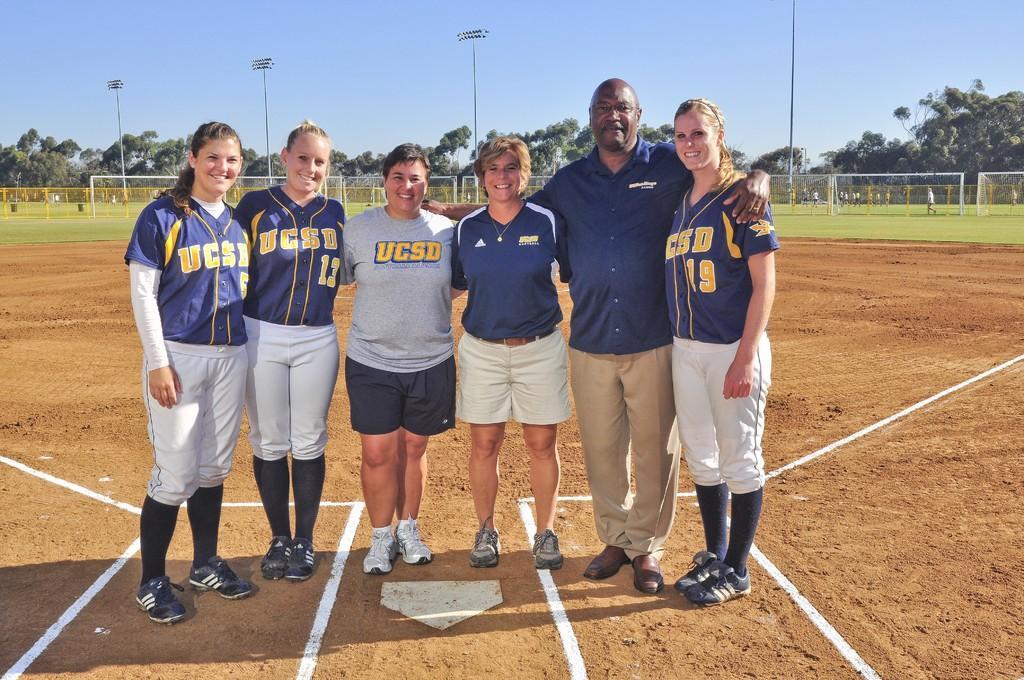Please provide a concise description of this image. In this image, we can see few people are standing on the ground. They are watching and smiling. At the bottom, we can see white lines. Background there are so many trees, poles, rods, few people and clear sky. 